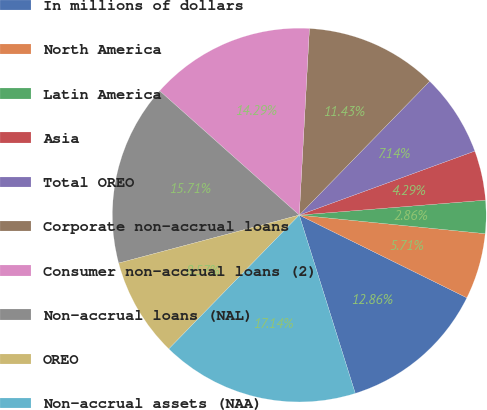Convert chart to OTSL. <chart><loc_0><loc_0><loc_500><loc_500><pie_chart><fcel>In millions of dollars<fcel>North America<fcel>Latin America<fcel>Asia<fcel>Total OREO<fcel>Corporate non-accrual loans<fcel>Consumer non-accrual loans (2)<fcel>Non-accrual loans (NAL)<fcel>OREO<fcel>Non-accrual assets (NAA)<nl><fcel>12.86%<fcel>5.71%<fcel>2.86%<fcel>4.29%<fcel>7.14%<fcel>11.43%<fcel>14.29%<fcel>15.71%<fcel>8.57%<fcel>17.14%<nl></chart> 